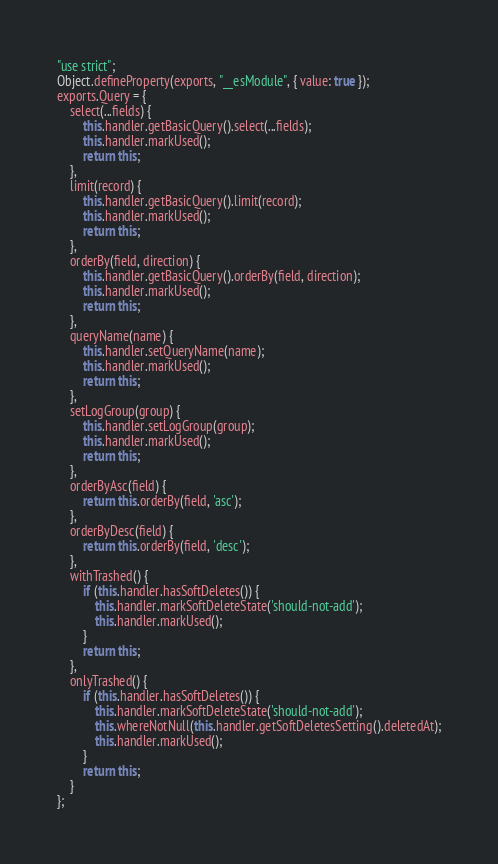<code> <loc_0><loc_0><loc_500><loc_500><_JavaScript_>"use strict";
Object.defineProperty(exports, "__esModule", { value: true });
exports.Query = {
    select(...fields) {
        this.handler.getBasicQuery().select(...fields);
        this.handler.markUsed();
        return this;
    },
    limit(record) {
        this.handler.getBasicQuery().limit(record);
        this.handler.markUsed();
        return this;
    },
    orderBy(field, direction) {
        this.handler.getBasicQuery().orderBy(field, direction);
        this.handler.markUsed();
        return this;
    },
    queryName(name) {
        this.handler.setQueryName(name);
        this.handler.markUsed();
        return this;
    },
    setLogGroup(group) {
        this.handler.setLogGroup(group);
        this.handler.markUsed();
        return this;
    },
    orderByAsc(field) {
        return this.orderBy(field, 'asc');
    },
    orderByDesc(field) {
        return this.orderBy(field, 'desc');
    },
    withTrashed() {
        if (this.handler.hasSoftDeletes()) {
            this.handler.markSoftDeleteState('should-not-add');
            this.handler.markUsed();
        }
        return this;
    },
    onlyTrashed() {
        if (this.handler.hasSoftDeletes()) {
            this.handler.markSoftDeleteState('should-not-add');
            this.whereNotNull(this.handler.getSoftDeletesSetting().deletedAt);
            this.handler.markUsed();
        }
        return this;
    }
};
</code> 